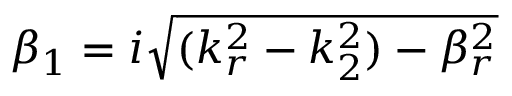<formula> <loc_0><loc_0><loc_500><loc_500>\beta _ { 1 } = i \sqrt { ( k _ { r } ^ { 2 } - k _ { 2 } ^ { 2 } ) - \beta _ { r } ^ { 2 } }</formula> 